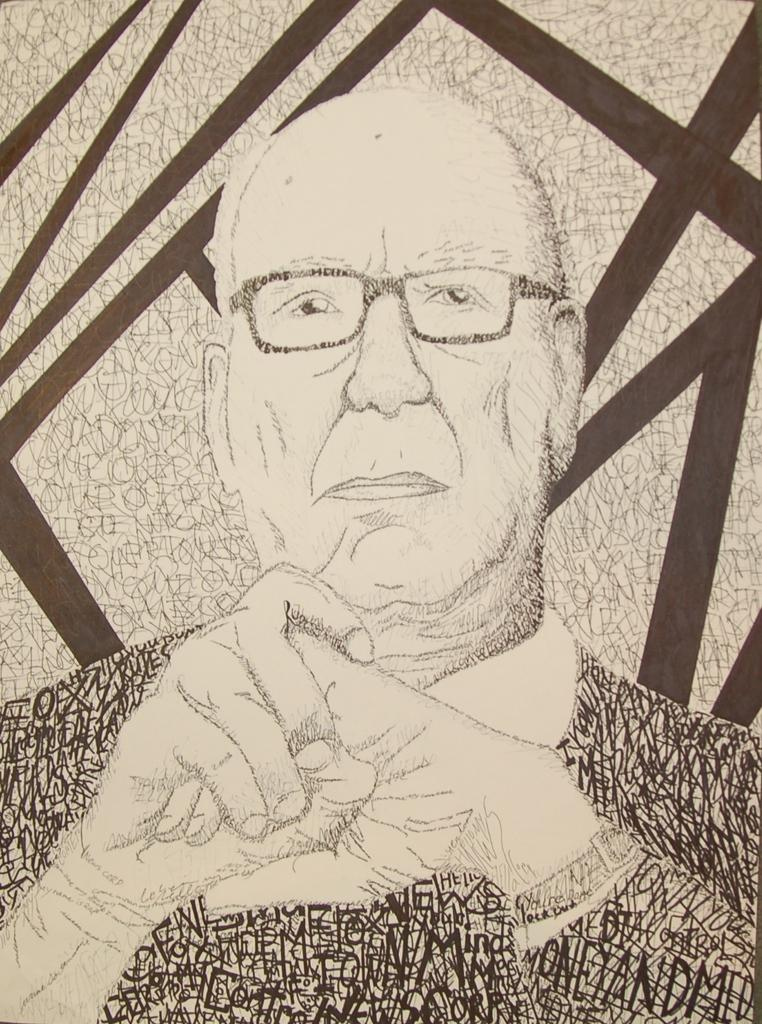What is depicted in the image? There is a drawing of a person in the image. Can you describe the person in the drawing? The person in the drawing is wearing specs. What type of gate can be seen in the drawing of the person? There is no gate present in the drawing of the person; it is a drawing of a person wearing specs. 